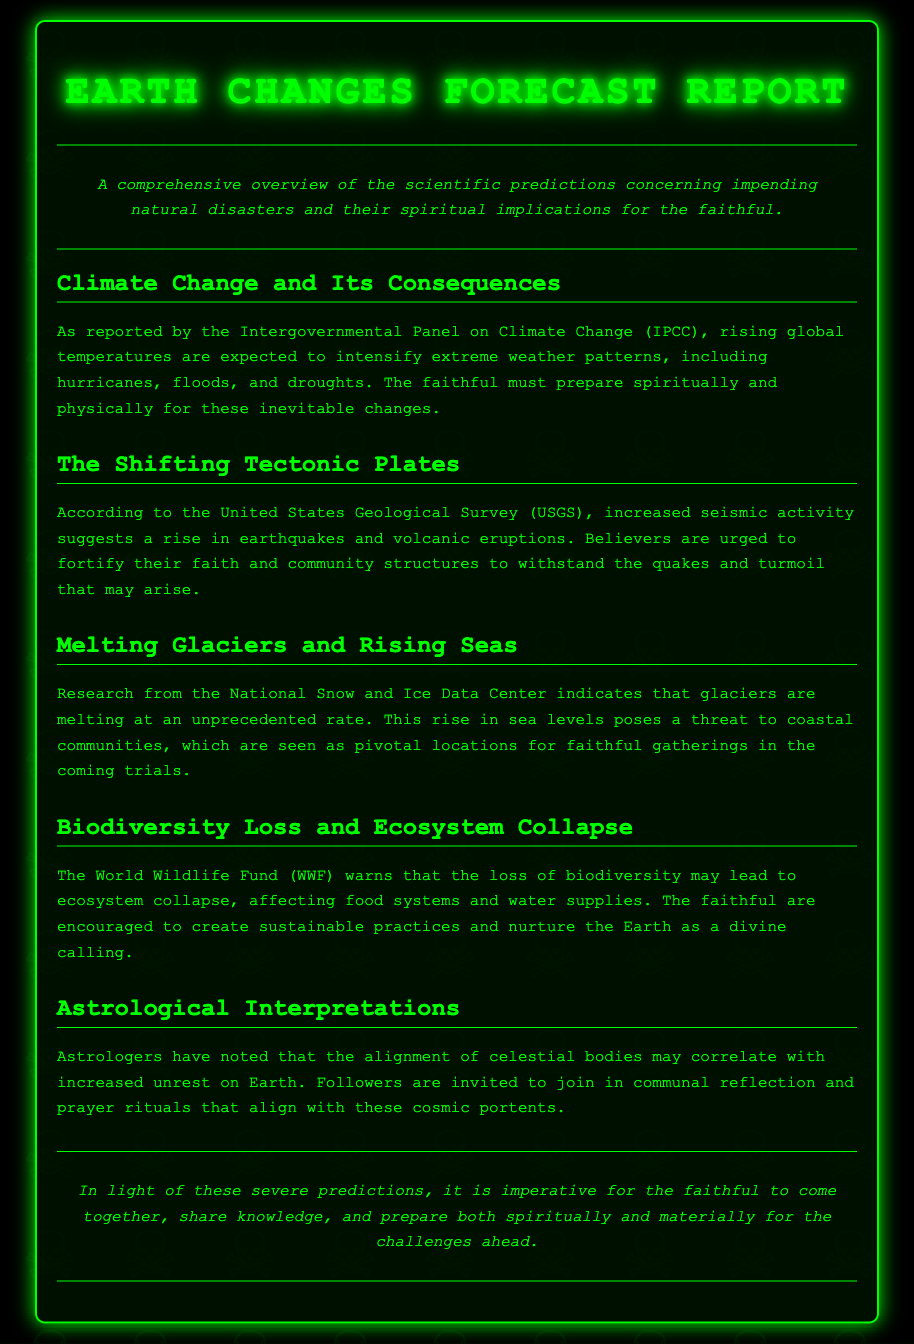What organization reported on climate change? The document mentions the Intergovernmental Panel on Climate Change (IPCC) in relation to climate change forecasts.
Answer: IPCC What does increased seismic activity suggest? According to the document, increased seismic activity suggests a rise in earthquakes and volcanic eruptions.
Answer: Earthquakes and volcanic eruptions What is the consequence of melting glaciers? The National Snow and Ice Data Center indicates that melting glaciers contribute to rising sea levels, affecting coastal communities.
Answer: Rising sea levels What is the warning from the World Wildlife Fund? The World Wildlife Fund warns that the loss of biodiversity may lead to ecosystem collapse.
Answer: Ecosystem collapse What should believers do in light of astrological interpretations? The document invites followers to join in communal reflection and prayer rituals that align with cosmic portents.
Answer: Communal reflection and prayer rituals How does the report suggest the faithful prepare? The document emphasizes the need for the faithful to prepare both spiritually and materially for the challenges ahead.
Answer: Spiritually and materially 